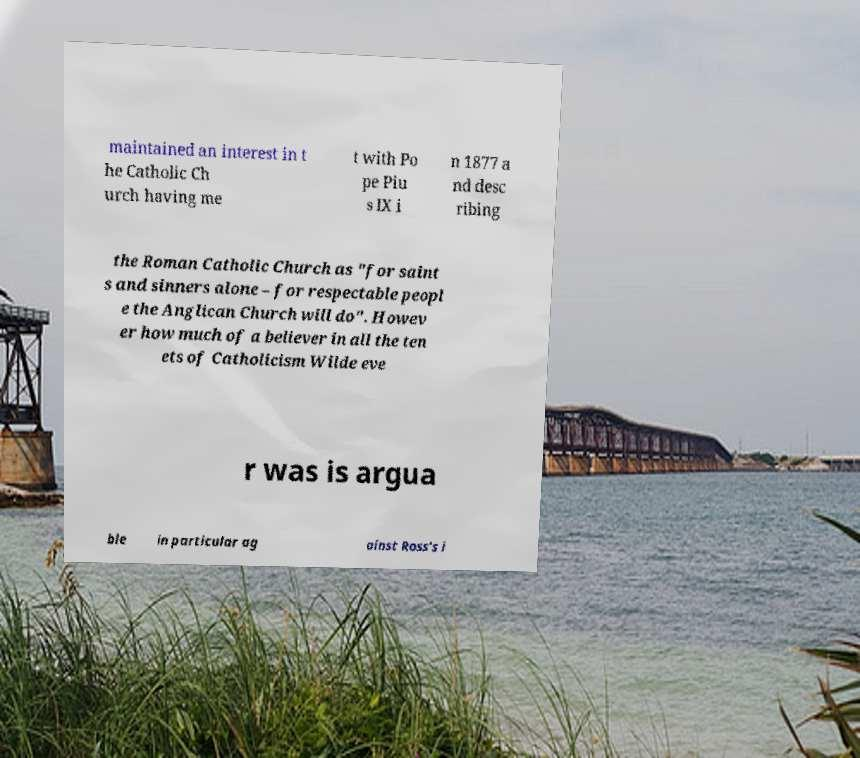Please read and relay the text visible in this image. What does it say? maintained an interest in t he Catholic Ch urch having me t with Po pe Piu s IX i n 1877 a nd desc ribing the Roman Catholic Church as "for saint s and sinners alone – for respectable peopl e the Anglican Church will do". Howev er how much of a believer in all the ten ets of Catholicism Wilde eve r was is argua ble in particular ag ainst Ross's i 